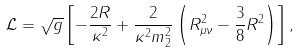Convert formula to latex. <formula><loc_0><loc_0><loc_500><loc_500>\mathcal { L } = \sqrt { g } \left [ - \frac { 2 R } { \kappa ^ { 2 } } + \frac { 2 } { \kappa ^ { 2 } m _ { 2 } ^ { 2 } } \left ( R ^ { 2 } _ { \mu \nu } - \frac { 3 } { 8 } R ^ { 2 } \right ) \right ] ,</formula> 